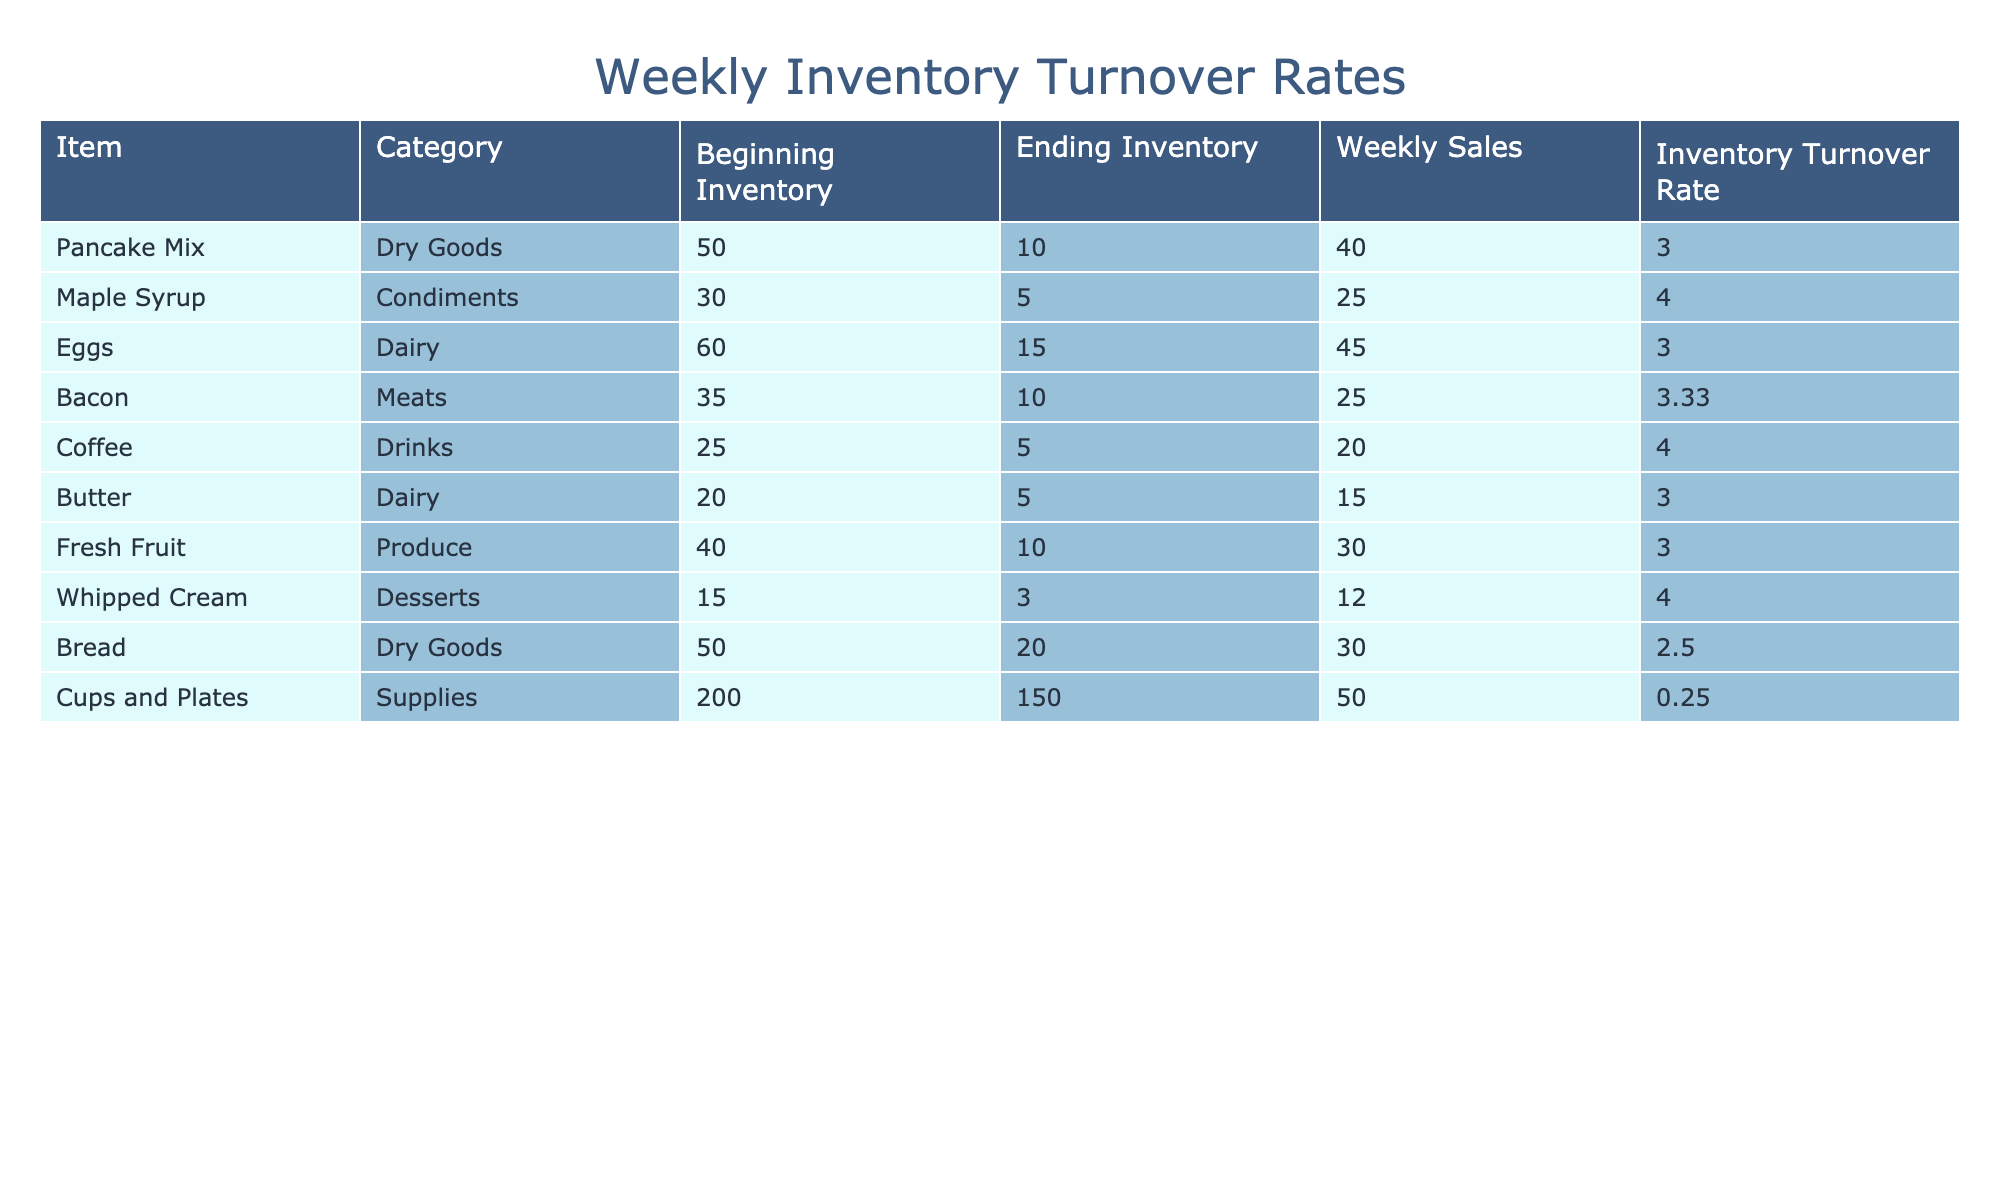What is the inventory turnover rate for pancake mix? The table shows that the inventory turnover rate for pancake mix is listed in the "Inventory Turnover Rate" column as 3.00.
Answer: 3.00 Which item has the highest inventory turnover rate? By looking at the "Inventory Turnover Rate" column, the item with the highest rate is maple syrup, which has a turnover rate of 4.00.
Answer: Maple syrup How many eggs were sold during the week? The "Weekly Sales" column indicates that 45 eggs were sold during the week, as listed under the eggs row.
Answer: 45 If butter was used up about 75% during the week, what was its weekly sales figure? To calculate the weekly sales figure for butter, we note that it has an ending inventory of 5, which means its beginning inventory of 20 must have been reduced by about 75%. Thus, the sales figure is 20 - 5 = 15.
Answer: 15 Is the average inventory turnover rate for dairy products greater than 3.00? The dairy products listed in the table are eggs and butter. Their turnover rates are both 3.00, and calculating the average gives (3.00 + 3.00)/2 = 3.00. Since the average is not greater than 3.00, the answer is no.
Answer: No What is the difference in the weekly sales between coffee and bacon? Looking at the "Weekly Sales," coffee has sales of 20, and bacon has 25. The difference is 25 - 20 = 5.
Answer: 5 Which supplies had an inventory turnover rate below 1? By examining the turnover rates in the table, only cups and plates have a turnover rate of 0.25, which is below 1.
Answer: Cups and plates What is the total weekly sales for dry goods? The dry goods listed are pancake mix and bread. Their weekly sales are 40 for pancake mix and 30 for bread. Summing these gives a total of 40 + 30 = 70.
Answer: 70 How much fresh fruit was left at the end of the week? The ending inventory for fresh fruit is directly provided in the table and states that there were 10 left at the end of the week.
Answer: 10 